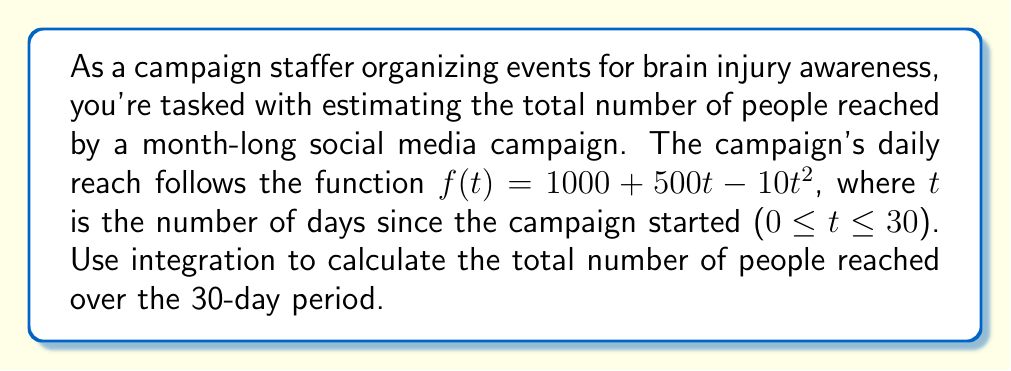Can you answer this question? To solve this problem, we need to integrate the given function over the specified time period. Here's the step-by-step solution:

1) The function representing daily reach is:
   $f(t) = 1000 + 500t - 10t^2$

2) To find the total reach over 30 days, we need to integrate this function from t = 0 to t = 30:

   $$\int_0^{30} (1000 + 500t - 10t^2) dt$$

3) Let's integrate each term separately:

   $$\int_0^{30} 1000 dt + \int_0^{30} 500t dt - \int_0^{30} 10t^2 dt$$

4) Evaluating each integral:
   
   - $\int 1000 dt = 1000t$
   - $\int 500t dt = 250t^2$
   - $\int 10t^2 dt = \frac{10}{3}t^3$

5) Applying the limits:

   $$[1000t + 250t^2 - \frac{10}{3}t^3]_0^{30}$$

6) Calculating the result:

   $$(30000 + 225000 - 90000) - (0 + 0 - 0)$$

7) Simplifying:

   $165000$

Therefore, the total number of people reached over the 30-day period is 165,000.
Answer: 165,000 people 